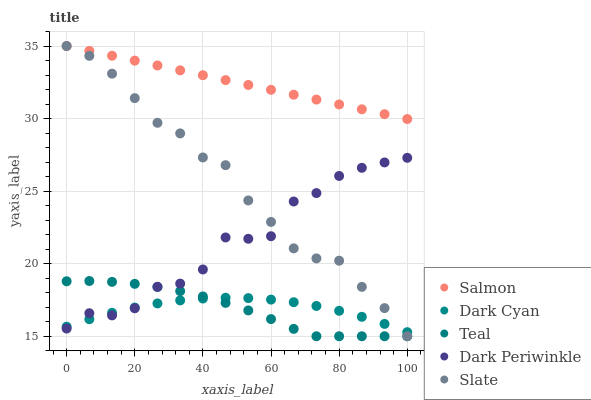Does Teal have the minimum area under the curve?
Answer yes or no. Yes. Does Salmon have the maximum area under the curve?
Answer yes or no. Yes. Does Slate have the minimum area under the curve?
Answer yes or no. No. Does Slate have the maximum area under the curve?
Answer yes or no. No. Is Salmon the smoothest?
Answer yes or no. Yes. Is Dark Periwinkle the roughest?
Answer yes or no. Yes. Is Slate the smoothest?
Answer yes or no. No. Is Slate the roughest?
Answer yes or no. No. Does Slate have the lowest value?
Answer yes or no. Yes. Does Salmon have the lowest value?
Answer yes or no. No. Does Salmon have the highest value?
Answer yes or no. Yes. Does Dark Periwinkle have the highest value?
Answer yes or no. No. Is Teal less than Salmon?
Answer yes or no. Yes. Is Salmon greater than Dark Cyan?
Answer yes or no. Yes. Does Slate intersect Dark Cyan?
Answer yes or no. Yes. Is Slate less than Dark Cyan?
Answer yes or no. No. Is Slate greater than Dark Cyan?
Answer yes or no. No. Does Teal intersect Salmon?
Answer yes or no. No. 